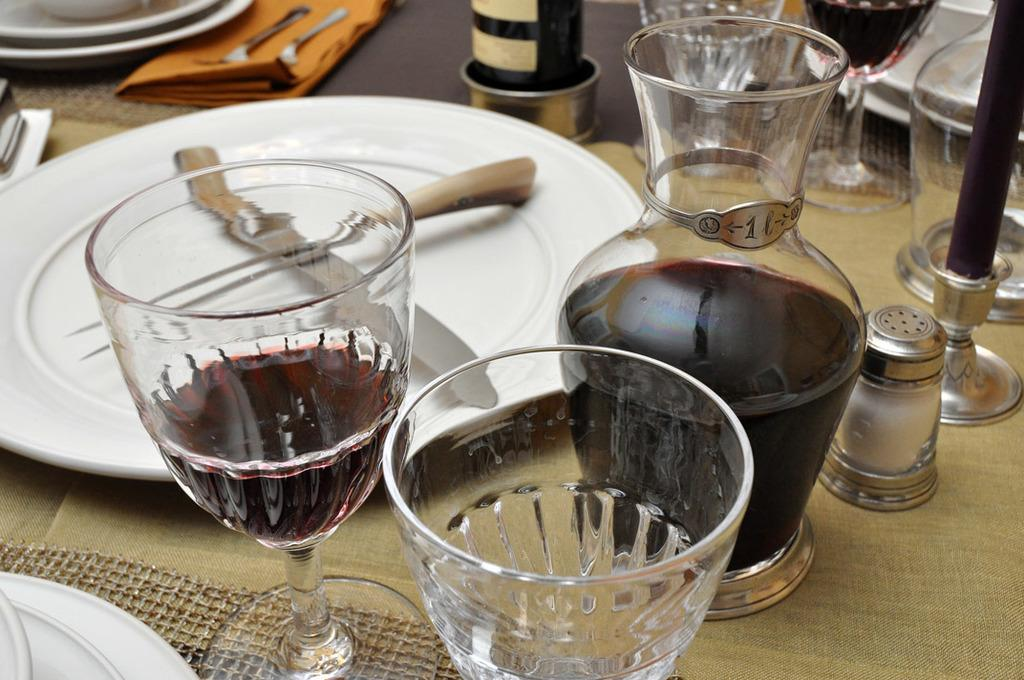What is present on the table in the image? There is a plate and glasses in the image. Are there any other objects on the table besides the plate and glasses? Yes, there are other objects on the table in the image. Can you describe the plate in the image? Unfortunately, the facts provided do not give any details about the plate. How is the honey being used to create force in the image? There is no honey present in the image, so it cannot be used to create force. 